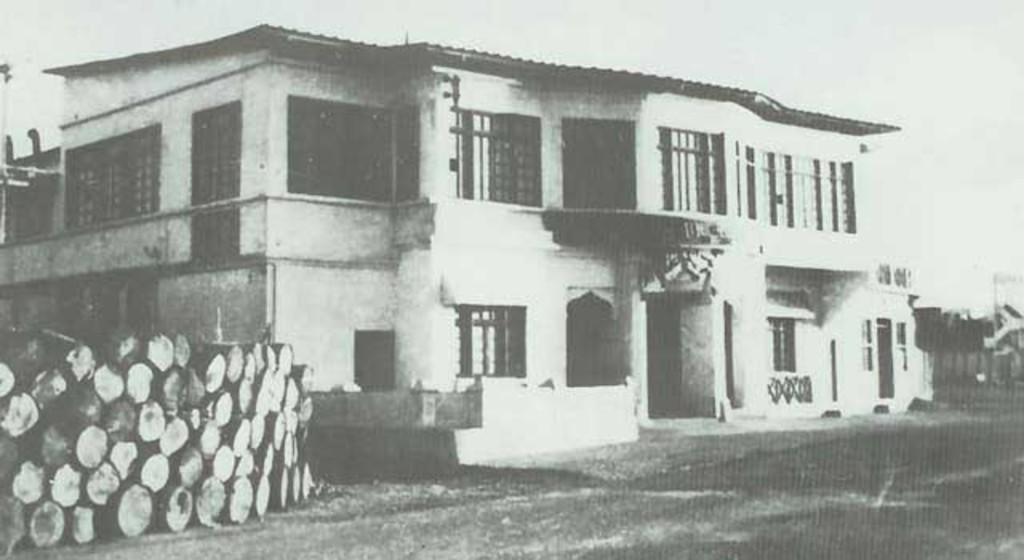What is the color scheme of the image? The image is black and white. What structure can be seen in the image? There is a house in the image. What is located on the left side of the image? There are logs on the left side of the image. What is visible at the top of the image? The sky is visible at the top of the image. Can you see a snail crawling on the roof of the house in the image? There is no snail visible on the roof of the house in the image. 